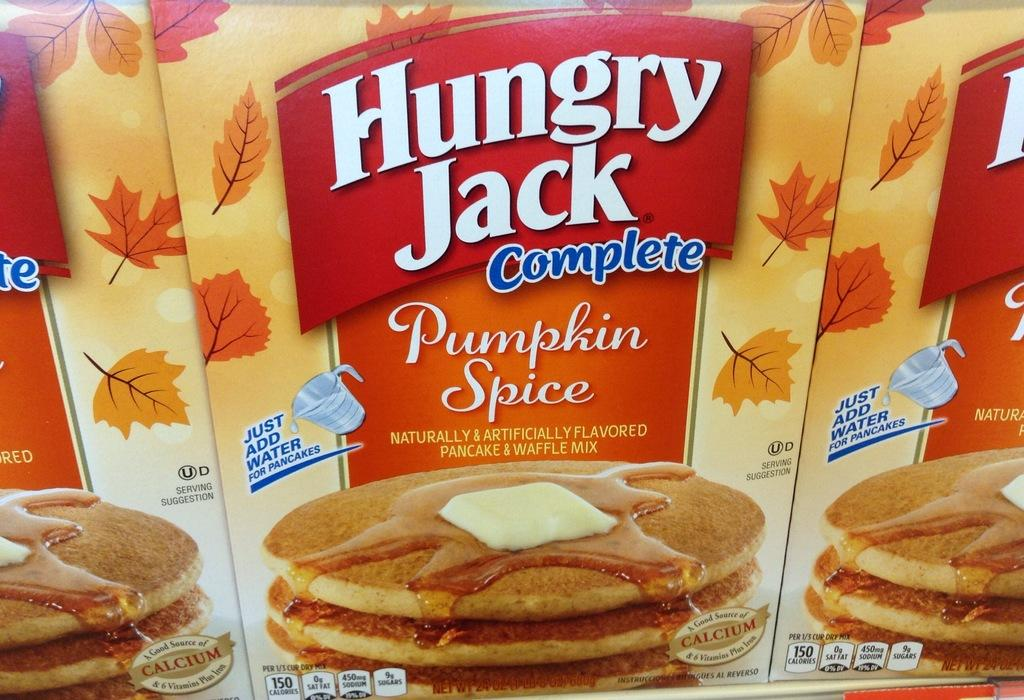What type of items are visible in the image? There are food packets in the image. Can you identify the brand of the food packets? Yes, the food packets have the name "Hungry Jacks" on them. What type of game is being played in the image? There is no game being played in the image; it only features food packets with the name "Hungry Jacks" on them. Can you smell the soup in the image? There is no soup present in the image, so it cannot be smelled. 